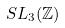Convert formula to latex. <formula><loc_0><loc_0><loc_500><loc_500>S L _ { 3 } ( \mathbb { Z } )</formula> 